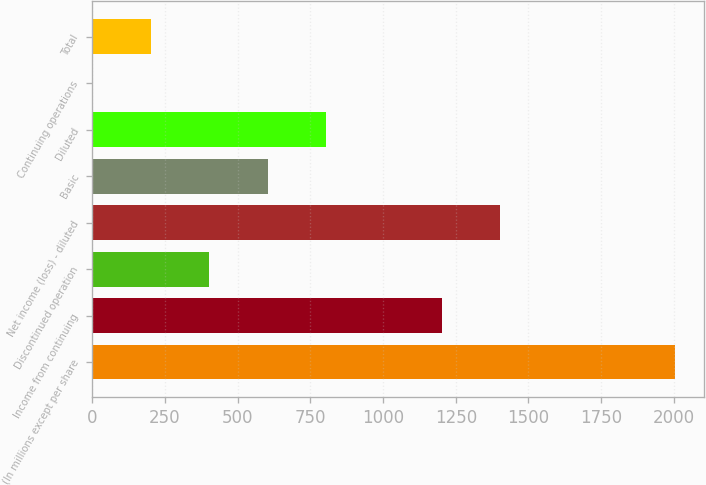Convert chart. <chart><loc_0><loc_0><loc_500><loc_500><bar_chart><fcel>(In millions except per share<fcel>Income from continuing<fcel>Discontinued operation<fcel>Net income (loss) - diluted<fcel>Basic<fcel>Diluted<fcel>Continuing operations<fcel>Total<nl><fcel>2004<fcel>1203.3<fcel>402.58<fcel>1403.48<fcel>602.76<fcel>802.94<fcel>2.22<fcel>202.4<nl></chart> 